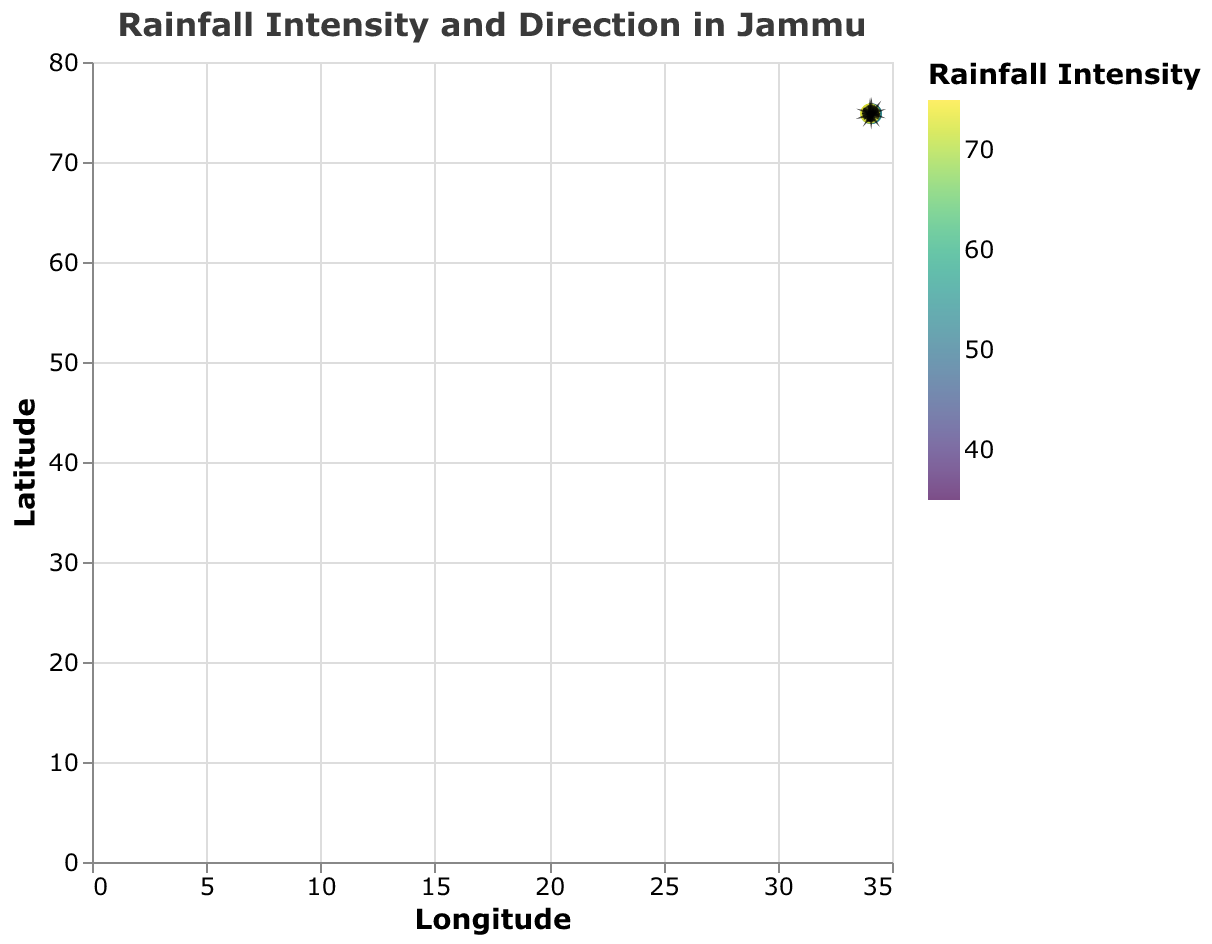What is the title of the plot? The title can be found at the top of the figure. It reads: "Rainfall Intensity and Direction in Jammu".
Answer: Rainfall Intensity and Direction in Jammu What variables are represented on the x and y-axis? The x-axis represents Longitude, and the y-axis represents Latitude. The labels on the axes show these variables.
Answer: Longitude and Latitude What is the highest recorded rainfall intensity, and at which coordinates is it located? The highest rainfall intensity is 75, which is located at the coordinates (34.04, 74.84). This can be observed from the color coding and the data values.
Answer: 75 at (34.04, 74.84) Which point has the smallest arrow, and what is its rainfall intensity? By looking at the plot, we can compare arrow lengths and refer to the color scale. The point with the smallest arrow is at (34.10, 74.88), and its rainfall intensity is 40.
Answer: Point at (34.10, 74.88) with intensity 40 What is the average rainfall intensity of all the points in the plot? Summing up all intensities (45 + 60 + 55 + 40 + 65 + 50 + 35 + 70 + 55 + 75) equals 550. There are 10 points, so the average intensity is 550/10 = 55.
Answer: 55 Which coordinate shows the least rainfall intensity and what is its direction in terms of u and v components? The lowest intensity is 35 at the coordinates (34.11, 74.83). The direction components are u = -2.4 and v = 2.0.
Answer: (34.11, 74.83) with u = -2.4 and v = 2.0 Between the points (34.08, 74.79) and (34.06, 74.87), which one has a higher rainfall intensity and what are their respective intensities? The intensity at (34.08, 74.79) is 45 and at (34.06, 74.87) is 70. Therefore, (34.06, 74.87) has a higher intensity.
Answer: (34.06, 74.87) with intensity 70 What is the most common direction (general u and v component pattern) observed in the arrows? Observing the visual direction of the arrows, most points have a u component around -2.5 to -3.2 and a v component around 1.5 to 2.3, generally pointing northwest.
Answer: Northwest How many points are displayed in the plot? The number of distinct pairs of coordinates indicates the number of points. Counting the data points, there are 10 points in total.
Answer: 10 What is the intensity range (difference between maximum and minimum intensities) in this plot? The highest intensity is 75, and the lowest intensity is 35. The difference is 75 - 35 = 40.
Answer: 40 